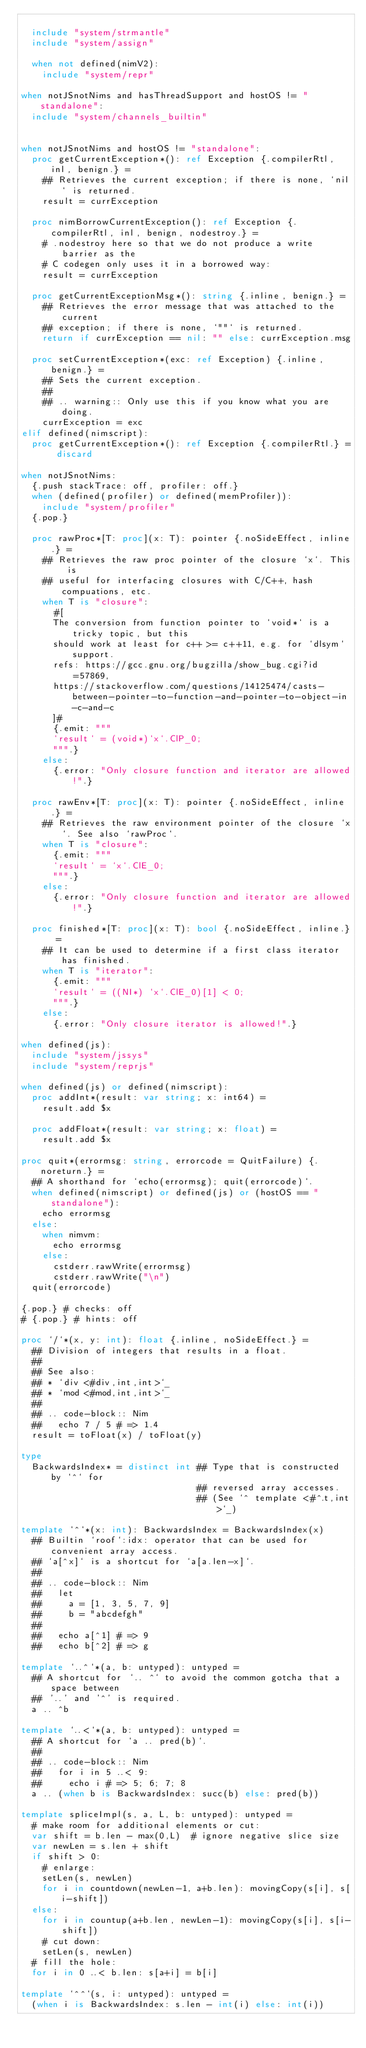Convert code to text. <code><loc_0><loc_0><loc_500><loc_500><_Nim_>
  include "system/strmantle"
  include "system/assign"

  when not defined(nimV2):
    include "system/repr"

when notJSnotNims and hasThreadSupport and hostOS != "standalone":
  include "system/channels_builtin"


when notJSnotNims and hostOS != "standalone":
  proc getCurrentException*(): ref Exception {.compilerRtl, inl, benign.} =
    ## Retrieves the current exception; if there is none, `nil` is returned.
    result = currException

  proc nimBorrowCurrentException(): ref Exception {.compilerRtl, inl, benign, nodestroy.} =
    # .nodestroy here so that we do not produce a write barrier as the
    # C codegen only uses it in a borrowed way:
    result = currException

  proc getCurrentExceptionMsg*(): string {.inline, benign.} =
    ## Retrieves the error message that was attached to the current
    ## exception; if there is none, `""` is returned.
    return if currException == nil: "" else: currException.msg

  proc setCurrentException*(exc: ref Exception) {.inline, benign.} =
    ## Sets the current exception.
    ##
    ## .. warning:: Only use this if you know what you are doing.
    currException = exc
elif defined(nimscript):
  proc getCurrentException*(): ref Exception {.compilerRtl.} = discard

when notJSnotNims:
  {.push stackTrace: off, profiler: off.}
  when (defined(profiler) or defined(memProfiler)):
    include "system/profiler"
  {.pop.}

  proc rawProc*[T: proc](x: T): pointer {.noSideEffect, inline.} =
    ## Retrieves the raw proc pointer of the closure `x`. This is
    ## useful for interfacing closures with C/C++, hash compuations, etc.
    when T is "closure":
      #[
      The conversion from function pointer to `void*` is a tricky topic, but this
      should work at least for c++ >= c++11, e.g. for `dlsym` support.
      refs: https://gcc.gnu.org/bugzilla/show_bug.cgi?id=57869,
      https://stackoverflow.com/questions/14125474/casts-between-pointer-to-function-and-pointer-to-object-in-c-and-c
      ]#
      {.emit: """
      `result` = (void*)`x`.ClP_0;
      """.}
    else:
      {.error: "Only closure function and iterator are allowed!".}

  proc rawEnv*[T: proc](x: T): pointer {.noSideEffect, inline.} =
    ## Retrieves the raw environment pointer of the closure `x`. See also `rawProc`.
    when T is "closure":
      {.emit: """
      `result` = `x`.ClE_0;
      """.}
    else:
      {.error: "Only closure function and iterator are allowed!".}

  proc finished*[T: proc](x: T): bool {.noSideEffect, inline.} =
    ## It can be used to determine if a first class iterator has finished.
    when T is "iterator":
      {.emit: """
      `result` = ((NI*) `x`.ClE_0)[1] < 0;
      """.}
    else:
      {.error: "Only closure iterator is allowed!".}

when defined(js):
  include "system/jssys"
  include "system/reprjs"

when defined(js) or defined(nimscript):
  proc addInt*(result: var string; x: int64) =
    result.add $x

  proc addFloat*(result: var string; x: float) =
    result.add $x

proc quit*(errormsg: string, errorcode = QuitFailure) {.noreturn.} =
  ## A shorthand for `echo(errormsg); quit(errorcode)`.
  when defined(nimscript) or defined(js) or (hostOS == "standalone"):
    echo errormsg
  else:
    when nimvm:
      echo errormsg
    else:
      cstderr.rawWrite(errormsg)
      cstderr.rawWrite("\n")
  quit(errorcode)

{.pop.} # checks: off
# {.pop.} # hints: off

proc `/`*(x, y: int): float {.inline, noSideEffect.} =
  ## Division of integers that results in a float.
  ##
  ## See also:
  ## * `div <#div,int,int>`_
  ## * `mod <#mod,int,int>`_
  ##
  ## .. code-block:: Nim
  ##   echo 7 / 5 # => 1.4
  result = toFloat(x) / toFloat(y)

type
  BackwardsIndex* = distinct int ## Type that is constructed by `^` for
                                 ## reversed array accesses.
                                 ## (See `^ template <#^.t,int>`_)

template `^`*(x: int): BackwardsIndex = BackwardsIndex(x)
  ## Builtin `roof`:idx: operator that can be used for convenient array access.
  ## `a[^x]` is a shortcut for `a[a.len-x]`.
  ##
  ## .. code-block:: Nim
  ##   let
  ##     a = [1, 3, 5, 7, 9]
  ##     b = "abcdefgh"
  ##
  ##   echo a[^1] # => 9
  ##   echo b[^2] # => g

template `..^`*(a, b: untyped): untyped =
  ## A shortcut for `.. ^` to avoid the common gotcha that a space between
  ## '..' and '^' is required.
  a .. ^b

template `..<`*(a, b: untyped): untyped =
  ## A shortcut for `a .. pred(b)`.
  ##
  ## .. code-block:: Nim
  ##   for i in 5 ..< 9:
  ##     echo i # => 5; 6; 7; 8
  a .. (when b is BackwardsIndex: succ(b) else: pred(b))

template spliceImpl(s, a, L, b: untyped): untyped =
  # make room for additional elements or cut:
  var shift = b.len - max(0,L)  # ignore negative slice size
  var newLen = s.len + shift
  if shift > 0:
    # enlarge:
    setLen(s, newLen)
    for i in countdown(newLen-1, a+b.len): movingCopy(s[i], s[i-shift])
  else:
    for i in countup(a+b.len, newLen-1): movingCopy(s[i], s[i-shift])
    # cut down:
    setLen(s, newLen)
  # fill the hole:
  for i in 0 ..< b.len: s[a+i] = b[i]

template `^^`(s, i: untyped): untyped =
  (when i is BackwardsIndex: s.len - int(i) else: int(i))
</code> 